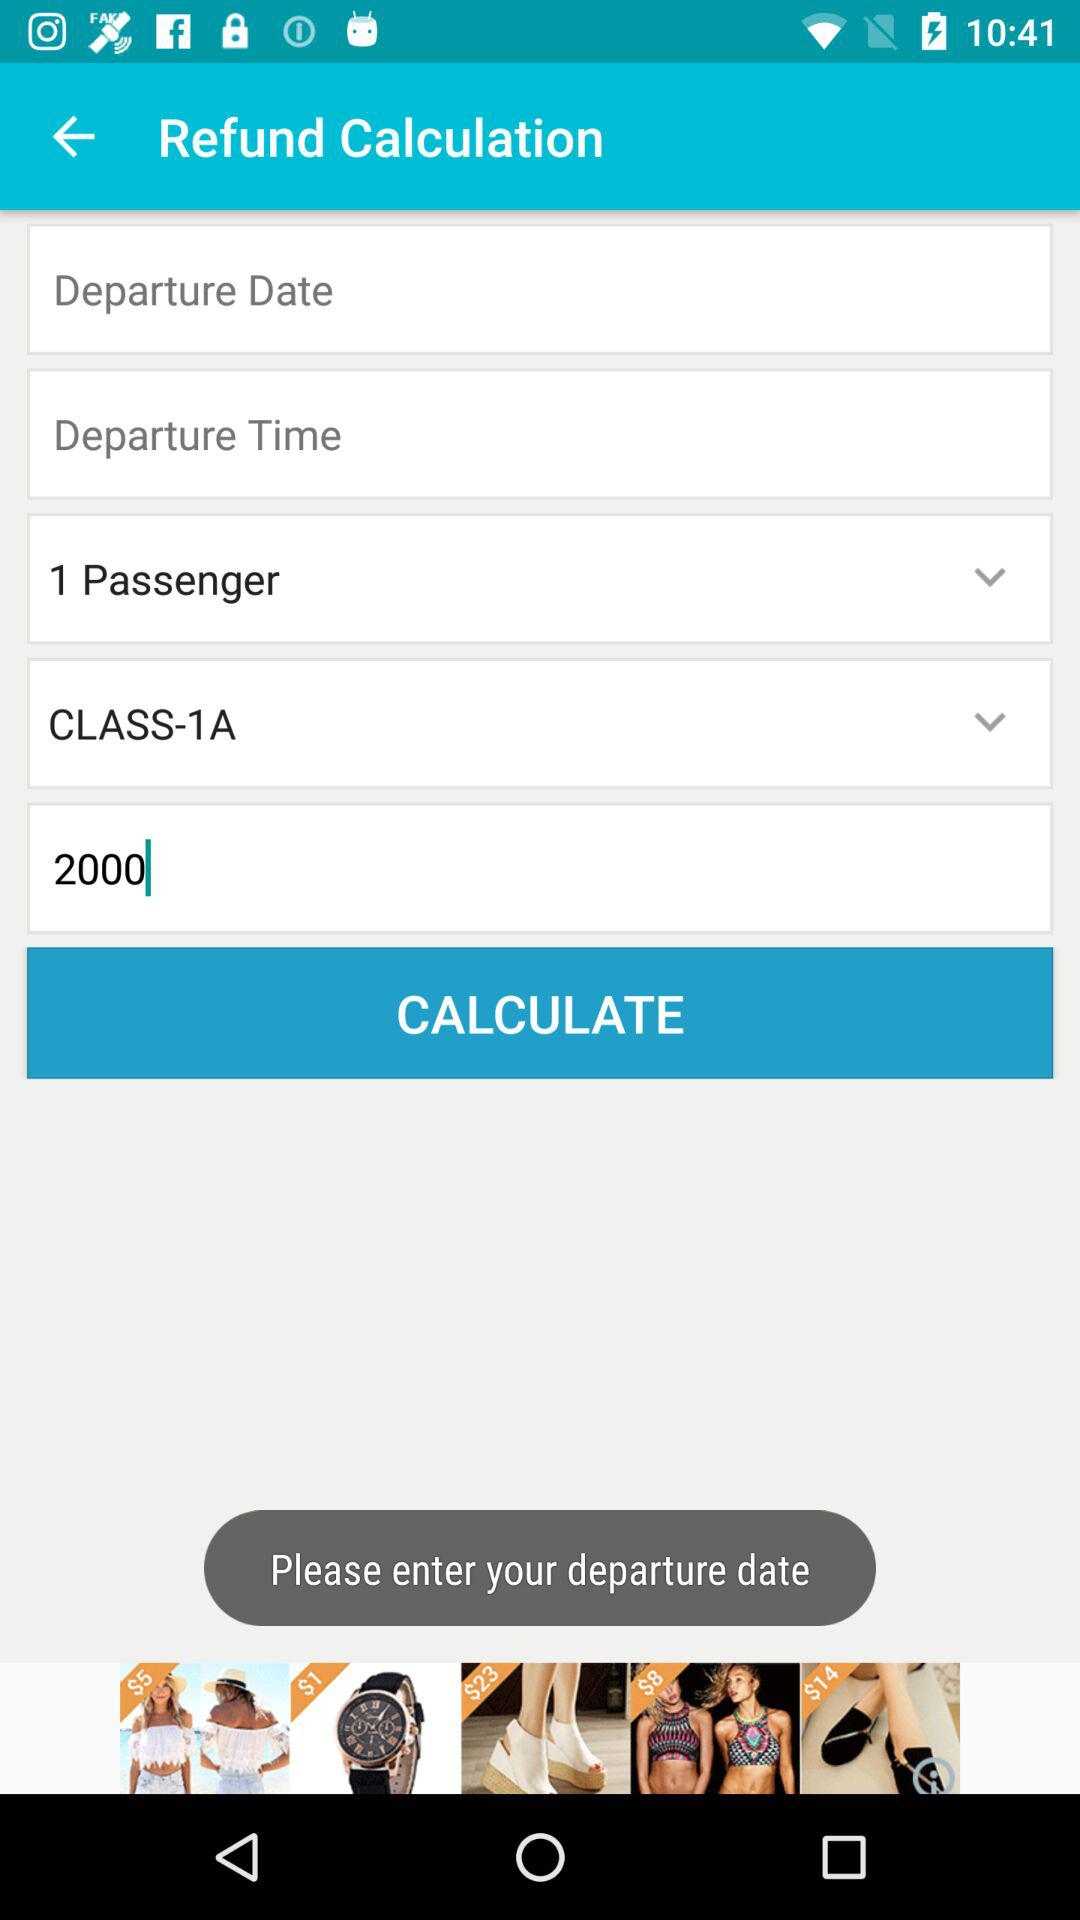For how many passengers does the person want the refund calculation? The person wants the refund calculation for 1 passenger. 